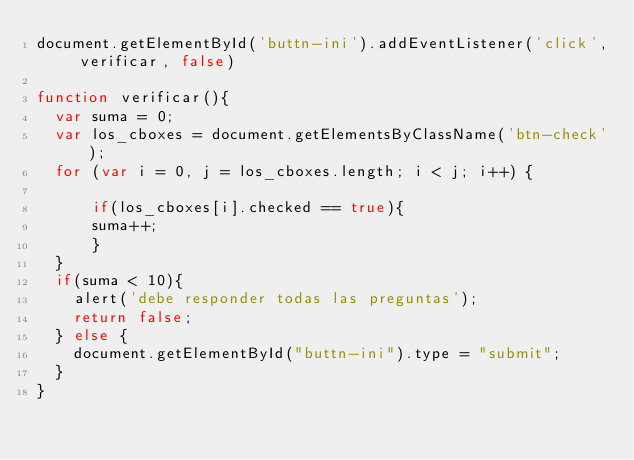<code> <loc_0><loc_0><loc_500><loc_500><_JavaScript_>document.getElementById('buttn-ini').addEventListener('click', verificar, false)

function verificar(){
  var suma = 0;
  var los_cboxes = document.getElementsByClassName('btn-check');
  for (var i = 0, j = los_cboxes.length; i < j; i++) {

      if(los_cboxes[i].checked == true){
      suma++;
      }
  }
  if(suma < 10){
    alert('debe responder todas las preguntas');
    return false;
  } else {
    document.getElementById("buttn-ini").type = "submit";
  }
}
</code> 